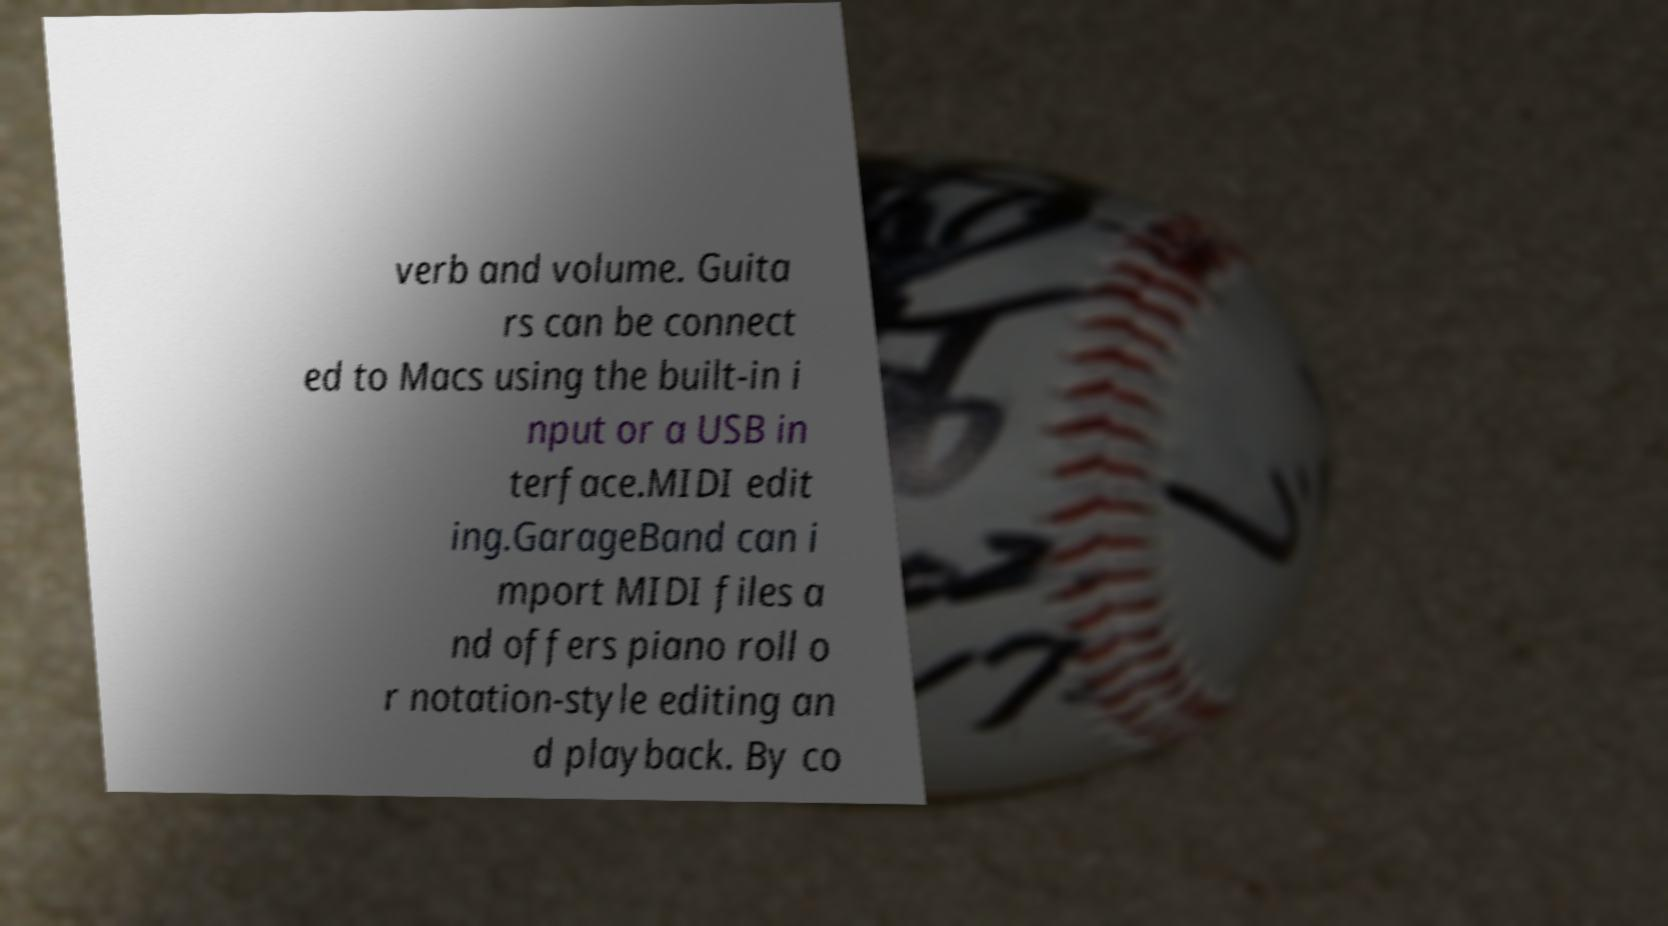What messages or text are displayed in this image? I need them in a readable, typed format. verb and volume. Guita rs can be connect ed to Macs using the built-in i nput or a USB in terface.MIDI edit ing.GarageBand can i mport MIDI files a nd offers piano roll o r notation-style editing an d playback. By co 